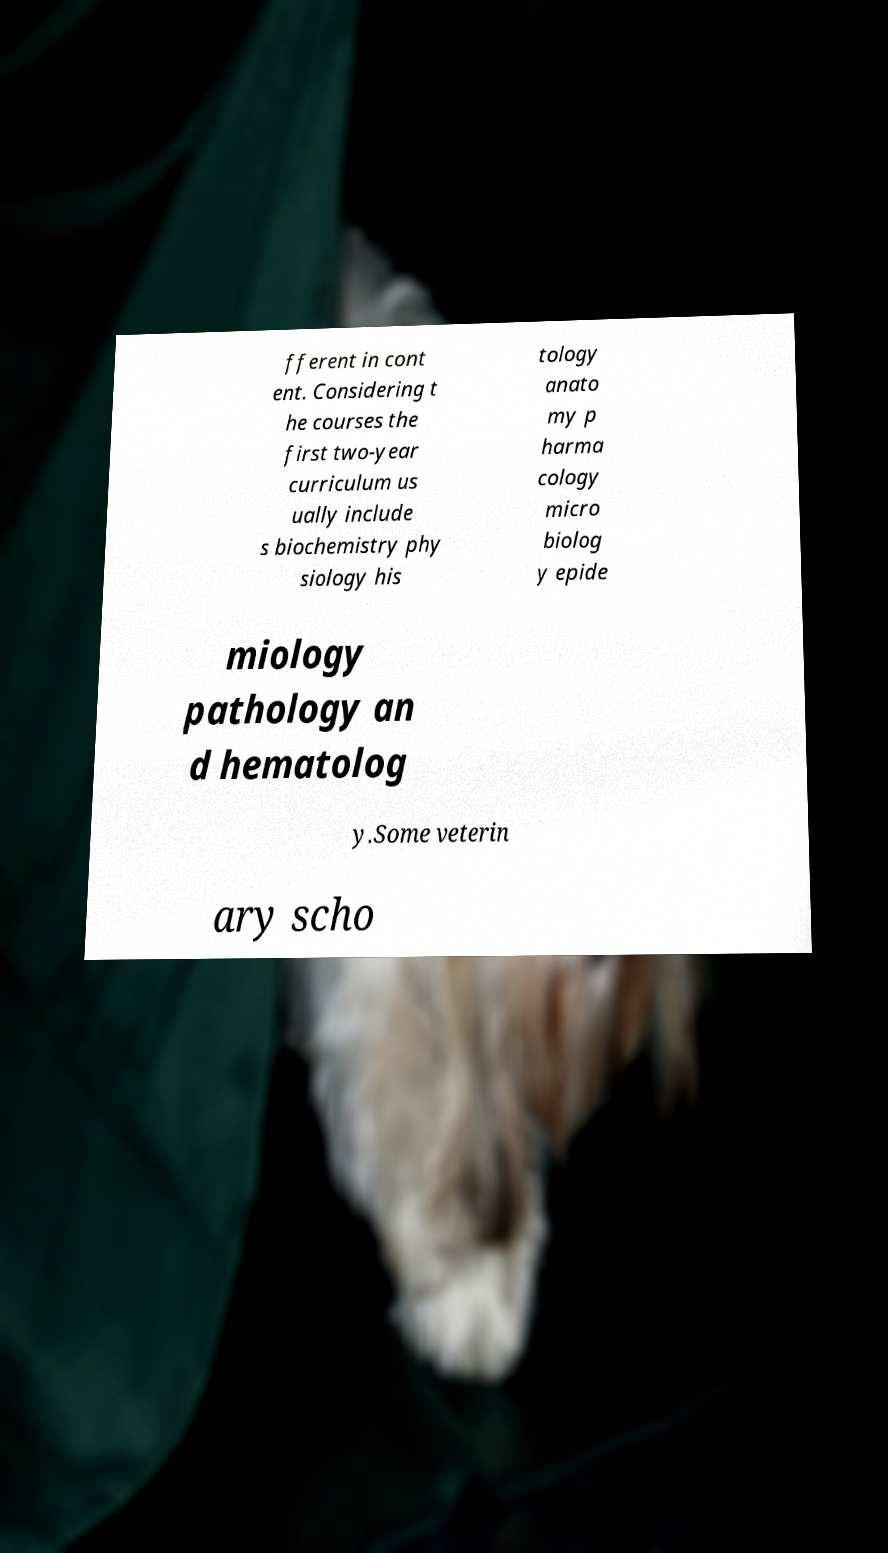Can you read and provide the text displayed in the image?This photo seems to have some interesting text. Can you extract and type it out for me? fferent in cont ent. Considering t he courses the first two-year curriculum us ually include s biochemistry phy siology his tology anato my p harma cology micro biolog y epide miology pathology an d hematolog y.Some veterin ary scho 